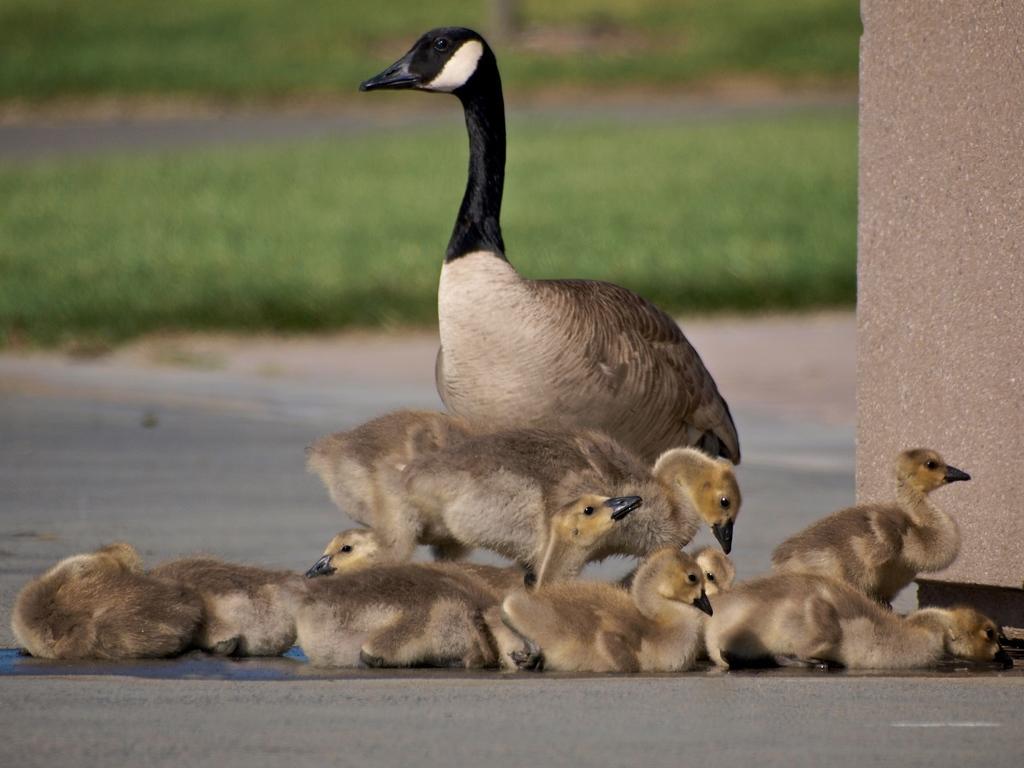How would you summarize this image in a sentence or two? In this image there is a duck and ducklings, in the background it is green and it is blurred. 